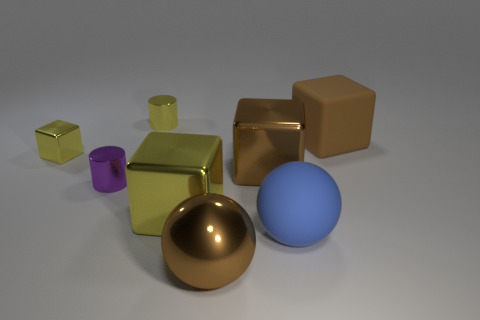Add 1 tiny yellow metallic cubes. How many objects exist? 9 Subtract all cylinders. How many objects are left? 6 Subtract 0 red balls. How many objects are left? 8 Subtract all large blue rubber spheres. Subtract all tiny yellow shiny blocks. How many objects are left? 6 Add 6 large rubber balls. How many large rubber balls are left? 7 Add 7 yellow cubes. How many yellow cubes exist? 9 